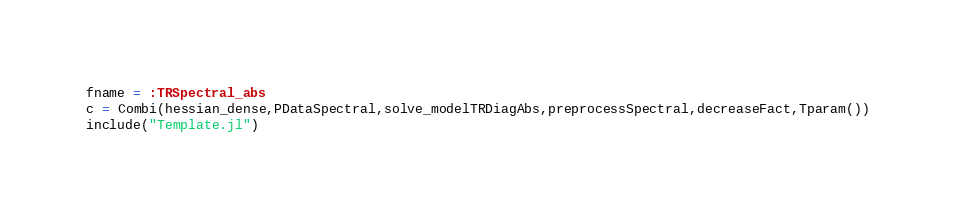Convert code to text. <code><loc_0><loc_0><loc_500><loc_500><_Julia_>fname = :TRSpectral_abs
c = Combi(hessian_dense,PDataSpectral,solve_modelTRDiagAbs,preprocessSpectral,decreaseFact,Tparam())
include("Template.jl")
</code> 